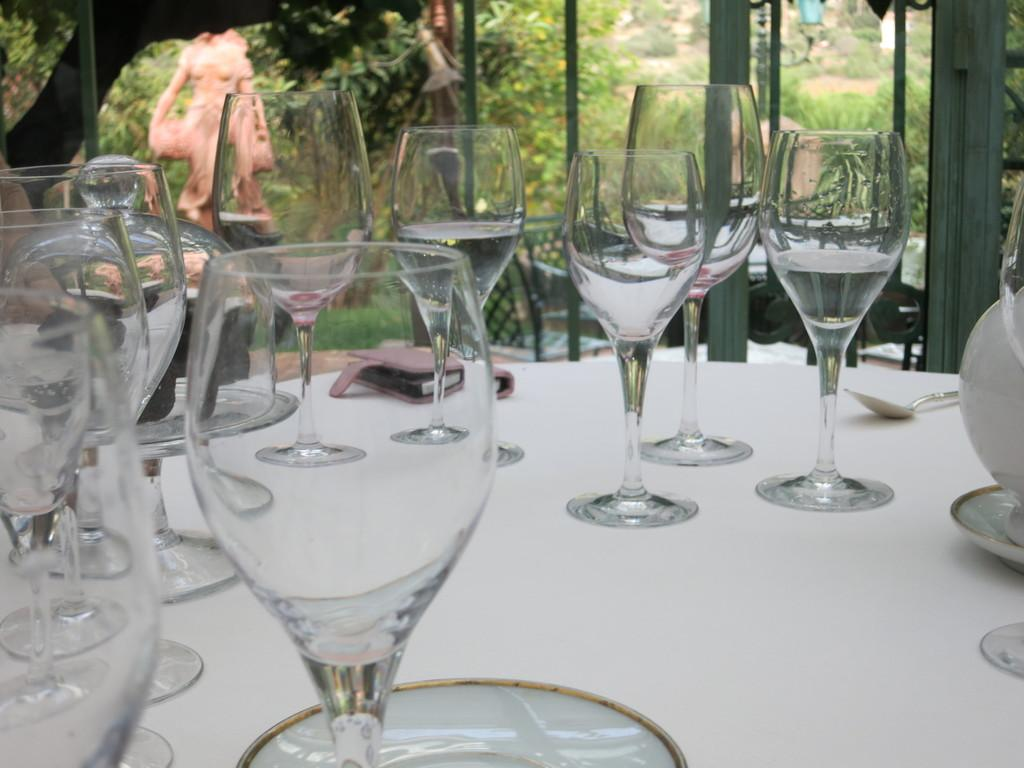What objects are on the table in the image? There are glasses, a spoon, and a valet on the table in the image. Can you describe the valet on the table? The valet on the table is an object typically used for holding clothes or accessories. What is visible in the background of the image? There is a window glass frame in the background. What did the father say during dinner in the image? There is no father or dinner scene present in the image, so it is not possible to answer that question. 